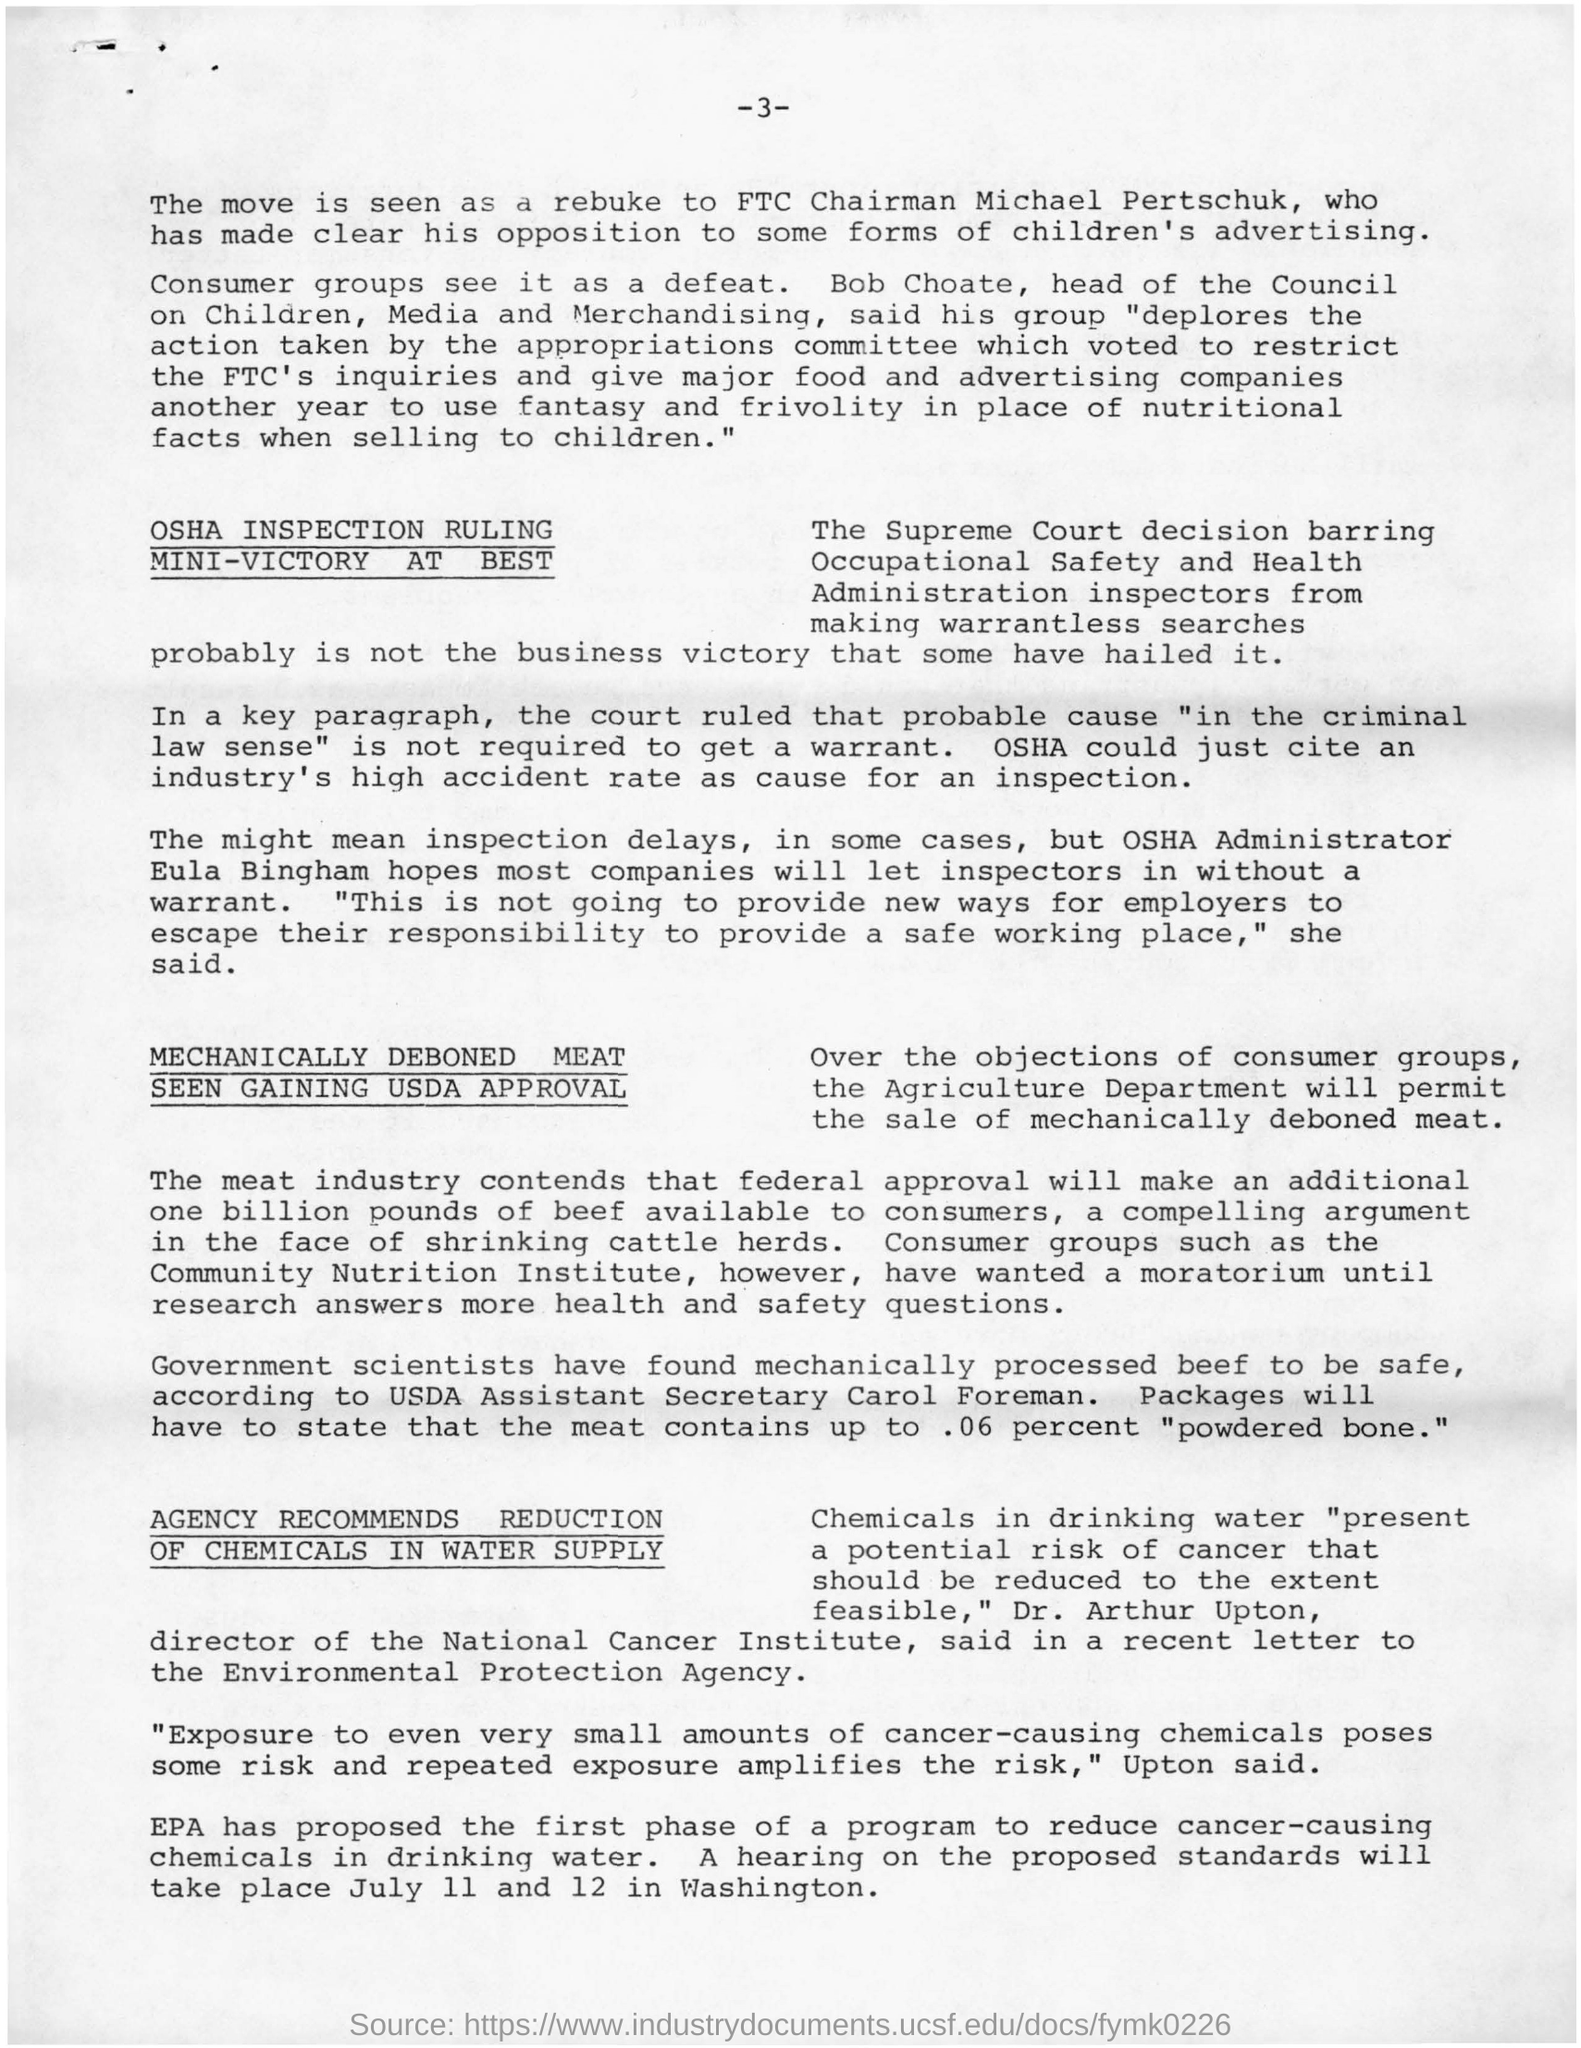Give some essential details in this illustration. Bob Choate was the head of the council. It was stated by Dr. Arthur Upton that chemicals should be reduced to the extent feasible. The drinking water contained chemicals, which was present. Consumer groups view the move as a defeat. 